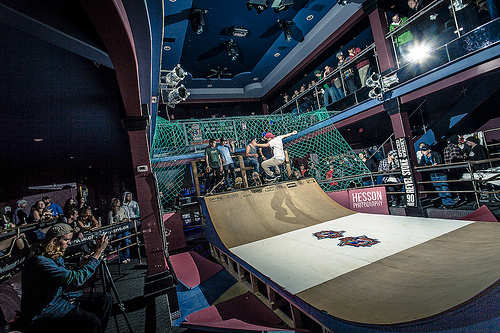<image>
Is there a skater above the ramp? Yes. The skater is positioned above the ramp in the vertical space, higher up in the scene. 